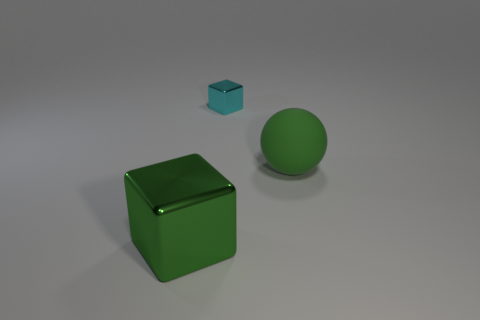What material is the large block that is the same color as the big rubber thing?
Provide a short and direct response. Metal. Is the material of the large object to the left of the large green matte sphere the same as the small cyan thing?
Your response must be concise. Yes. Is there a green object to the right of the green sphere on the right side of the cube behind the green ball?
Ensure brevity in your answer.  No. How many cylinders are either tiny objects or big green things?
Keep it short and to the point. 0. There is a green object that is left of the sphere; what is its material?
Keep it short and to the point. Metal. There is a thing in front of the green matte ball; does it have the same color as the large thing that is to the right of the big green block?
Keep it short and to the point. Yes. What number of objects are big balls or large green objects?
Give a very brief answer. 2. What number of other objects are there of the same shape as the tiny cyan metal thing?
Offer a terse response. 1. Do the big object to the right of the cyan block and the cube to the right of the large metallic object have the same material?
Provide a succinct answer. No. There is a thing that is both left of the green matte object and on the right side of the large block; what is its shape?
Your answer should be very brief. Cube. 